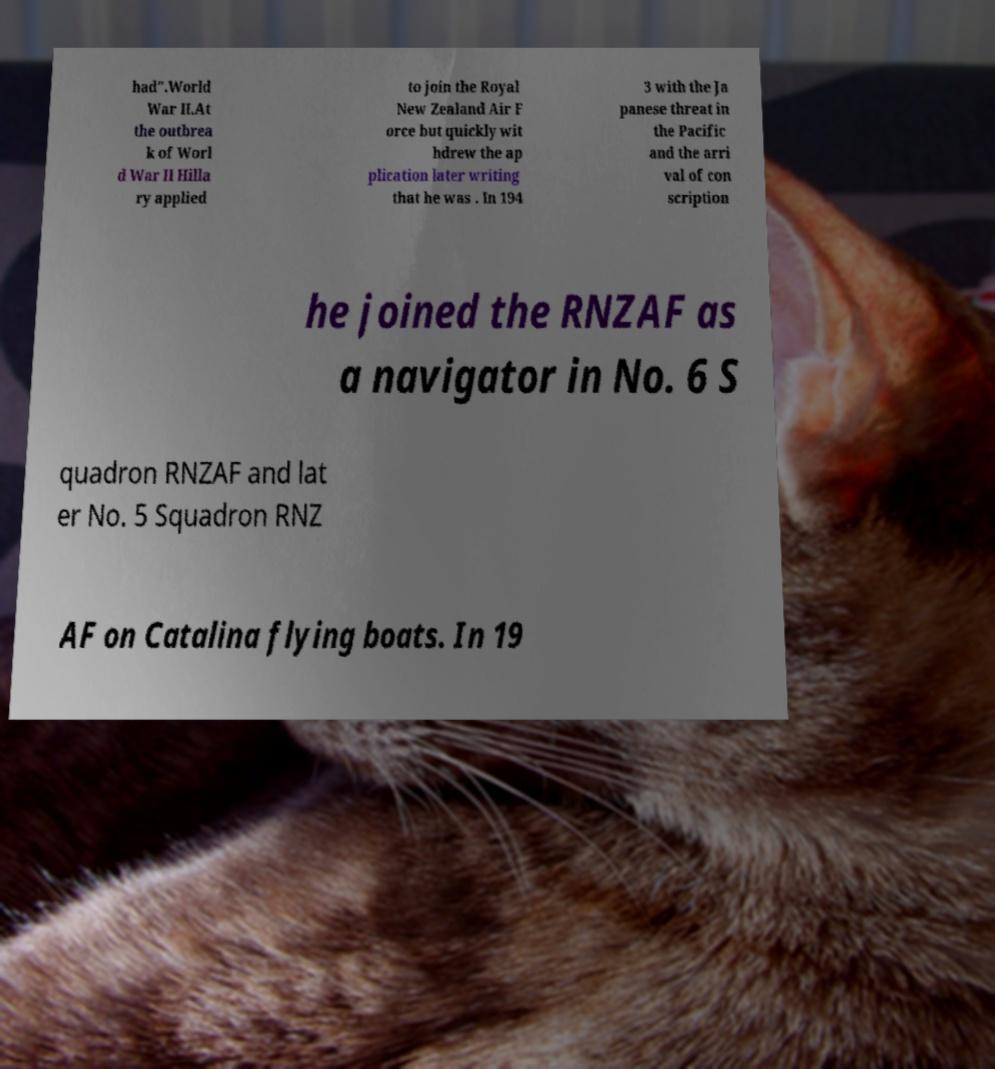What messages or text are displayed in this image? I need them in a readable, typed format. had".World War II.At the outbrea k of Worl d War II Hilla ry applied to join the Royal New Zealand Air F orce but quickly wit hdrew the ap plication later writing that he was . In 194 3 with the Ja panese threat in the Pacific and the arri val of con scription he joined the RNZAF as a navigator in No. 6 S quadron RNZAF and lat er No. 5 Squadron RNZ AF on Catalina flying boats. In 19 